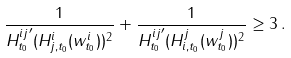Convert formula to latex. <formula><loc_0><loc_0><loc_500><loc_500>\frac { 1 } { { H _ { t _ { 0 } } ^ { i j } } ^ { \prime } ( H _ { j , t _ { 0 } } ^ { i } ( w _ { t _ { 0 } } ^ { i } ) ) ^ { 2 } } + \frac { 1 } { { H _ { t _ { 0 } } ^ { i j } } ^ { \prime } ( H _ { i , t _ { 0 } } ^ { j } ( w _ { t _ { 0 } } ^ { j } ) ) ^ { 2 } } \geq 3 \, .</formula> 